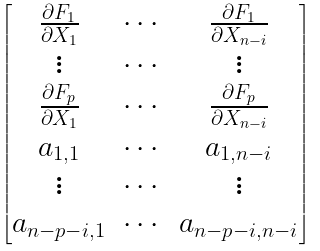Convert formula to latex. <formula><loc_0><loc_0><loc_500><loc_500>\begin{bmatrix} \frac { \partial F _ { 1 } } { \partial X _ { 1 } } & \cdots & \frac { \partial F _ { 1 } } { \partial X _ { n - i } } \\ \vdots & \cdots & \vdots \\ \frac { \partial F _ { p } } { \partial X _ { 1 } } & \cdots & \frac { \partial F _ { p } } { \partial X _ { n - i } } \\ a _ { 1 , 1 } & \cdots & a _ { 1 , n - i } \\ \vdots & \cdots & \vdots \\ a _ { n - p - i , 1 } & \cdots & a _ { n - p - i , n - i } \\ \end{bmatrix}</formula> 